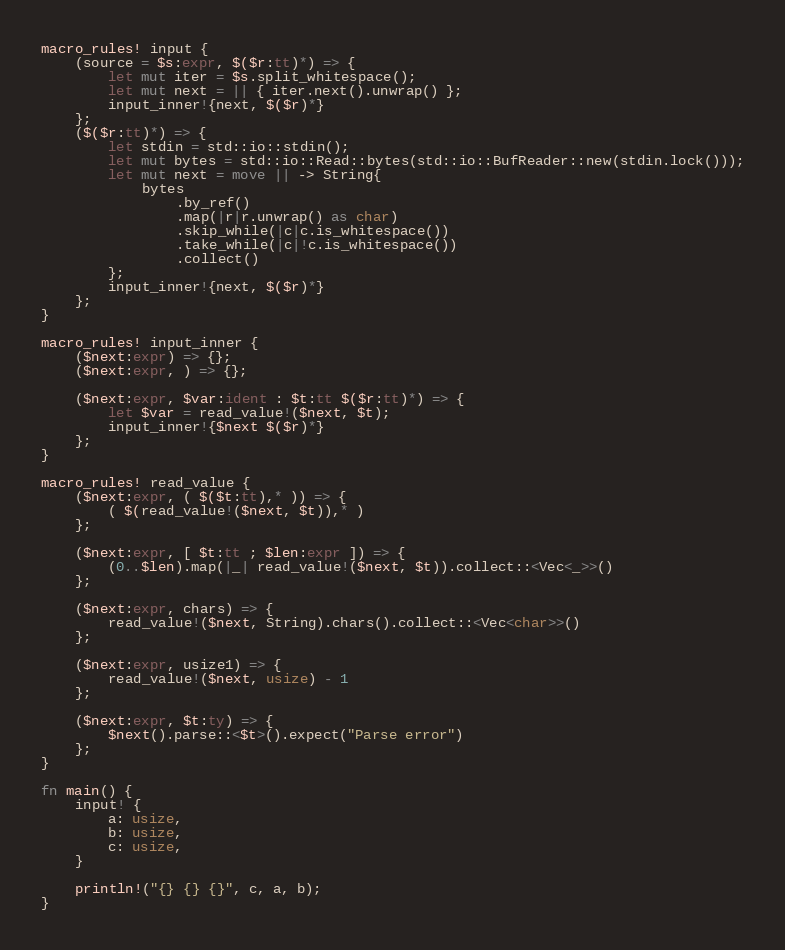Convert code to text. <code><loc_0><loc_0><loc_500><loc_500><_Rust_>macro_rules! input {
    (source = $s:expr, $($r:tt)*) => {
        let mut iter = $s.split_whitespace();
        let mut next = || { iter.next().unwrap() };
        input_inner!{next, $($r)*}
    };
    ($($r:tt)*) => {
        let stdin = std::io::stdin();
        let mut bytes = std::io::Read::bytes(std::io::BufReader::new(stdin.lock()));
        let mut next = move || -> String{
            bytes
                .by_ref()
                .map(|r|r.unwrap() as char)
                .skip_while(|c|c.is_whitespace())
                .take_while(|c|!c.is_whitespace())
                .collect()
        };
        input_inner!{next, $($r)*}
    };
}

macro_rules! input_inner {
    ($next:expr) => {};
    ($next:expr, ) => {};

    ($next:expr, $var:ident : $t:tt $($r:tt)*) => {
        let $var = read_value!($next, $t);
        input_inner!{$next $($r)*}
    };
}

macro_rules! read_value {
    ($next:expr, ( $($t:tt),* )) => {
        ( $(read_value!($next, $t)),* )
    };

    ($next:expr, [ $t:tt ; $len:expr ]) => {
        (0..$len).map(|_| read_value!($next, $t)).collect::<Vec<_>>()
    };

    ($next:expr, chars) => {
        read_value!($next, String).chars().collect::<Vec<char>>()
    };

    ($next:expr, usize1) => {
        read_value!($next, usize) - 1
    };

    ($next:expr, $t:ty) => {
        $next().parse::<$t>().expect("Parse error")
    };
}

fn main() {
    input! {
        a: usize,
        b: usize,
        c: usize,
    }

    println!("{} {} {}", c, a, b);
}
</code> 